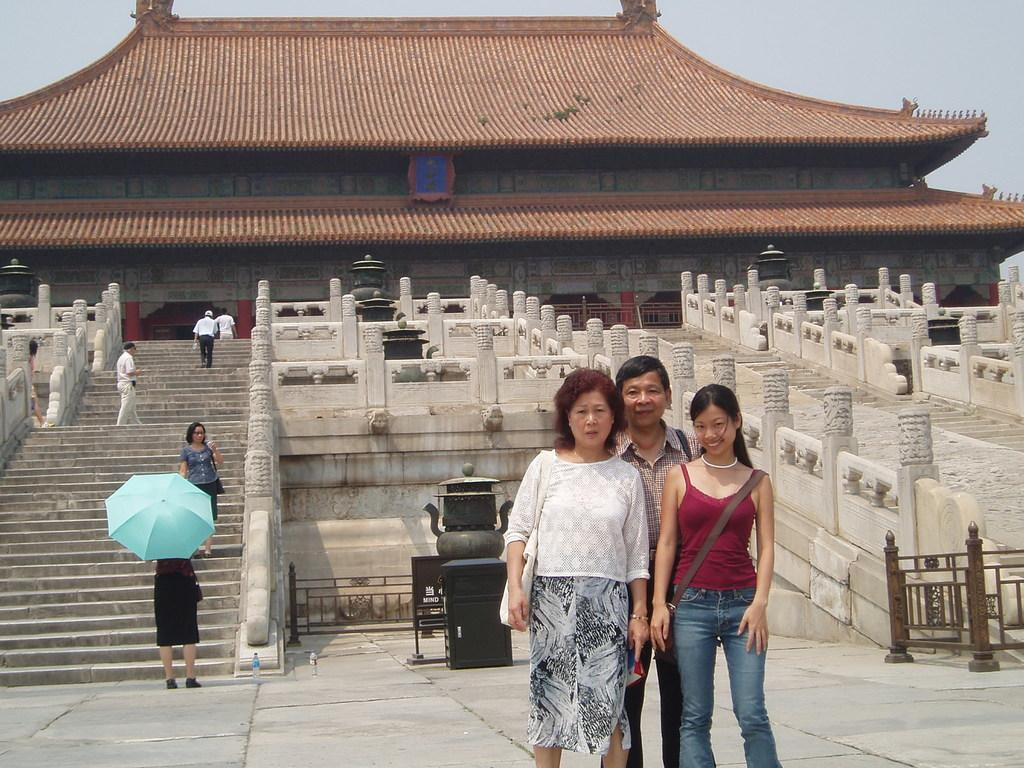How many people are in the image? There are three people standing on the path in the center of the image. What can be seen in the background of the image? There is a monument visible in the background, as well as stairs. What is visible in the sky in the image? The sky is visible in the image. Who is wearing a crown in the image? There is no one wearing a crown in the image. What force is being applied to the monument in the image? There is no force being applied to the monument in the image; it is stationary in the background. 